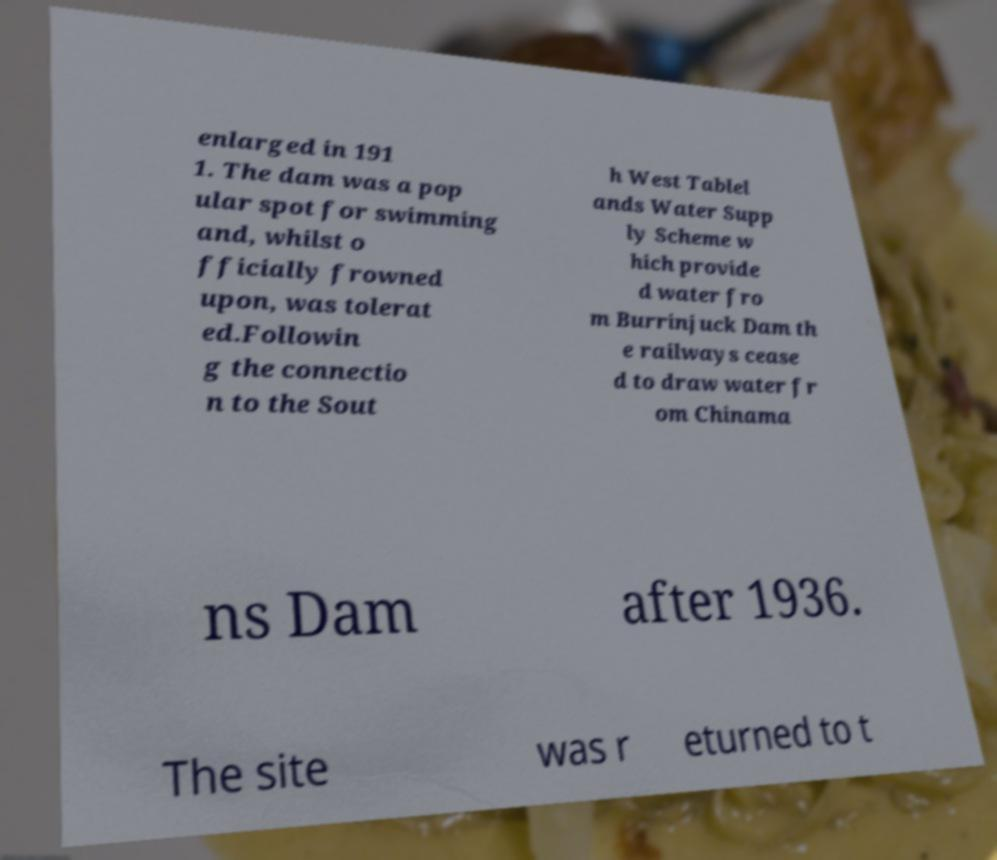Please identify and transcribe the text found in this image. enlarged in 191 1. The dam was a pop ular spot for swimming and, whilst o fficially frowned upon, was tolerat ed.Followin g the connectio n to the Sout h West Tablel ands Water Supp ly Scheme w hich provide d water fro m Burrinjuck Dam th e railways cease d to draw water fr om Chinama ns Dam after 1936. The site was r eturned to t 